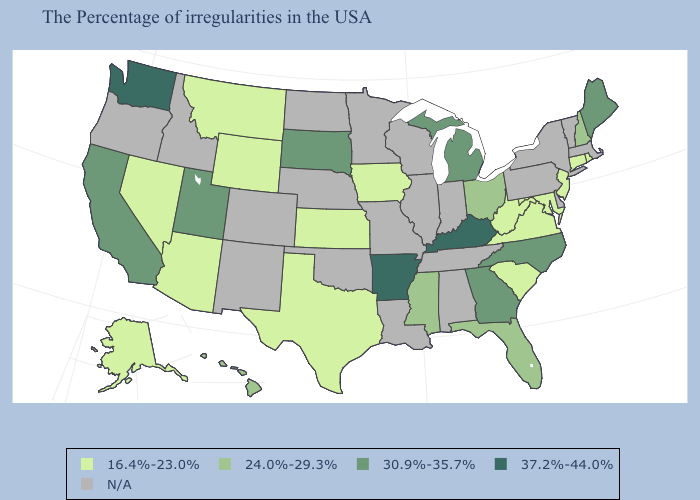Does Washington have the highest value in the West?
Quick response, please. Yes. What is the lowest value in states that border Virginia?
Answer briefly. 16.4%-23.0%. Name the states that have a value in the range N/A?
Short answer required. Massachusetts, Vermont, New York, Delaware, Pennsylvania, Indiana, Alabama, Tennessee, Wisconsin, Illinois, Louisiana, Missouri, Minnesota, Nebraska, Oklahoma, North Dakota, Colorado, New Mexico, Idaho, Oregon. Name the states that have a value in the range 16.4%-23.0%?
Be succinct. Rhode Island, Connecticut, New Jersey, Maryland, Virginia, South Carolina, West Virginia, Iowa, Kansas, Texas, Wyoming, Montana, Arizona, Nevada, Alaska. Which states hav the highest value in the West?
Short answer required. Washington. Name the states that have a value in the range 37.2%-44.0%?
Give a very brief answer. Kentucky, Arkansas, Washington. Does the first symbol in the legend represent the smallest category?
Answer briefly. Yes. Is the legend a continuous bar?
Be succinct. No. What is the lowest value in states that border California?
Concise answer only. 16.4%-23.0%. What is the value of New Jersey?
Be succinct. 16.4%-23.0%. What is the highest value in states that border Nebraska?
Concise answer only. 30.9%-35.7%. Name the states that have a value in the range 30.9%-35.7%?
Quick response, please. Maine, North Carolina, Georgia, Michigan, South Dakota, Utah, California. What is the lowest value in states that border Missouri?
Quick response, please. 16.4%-23.0%. 